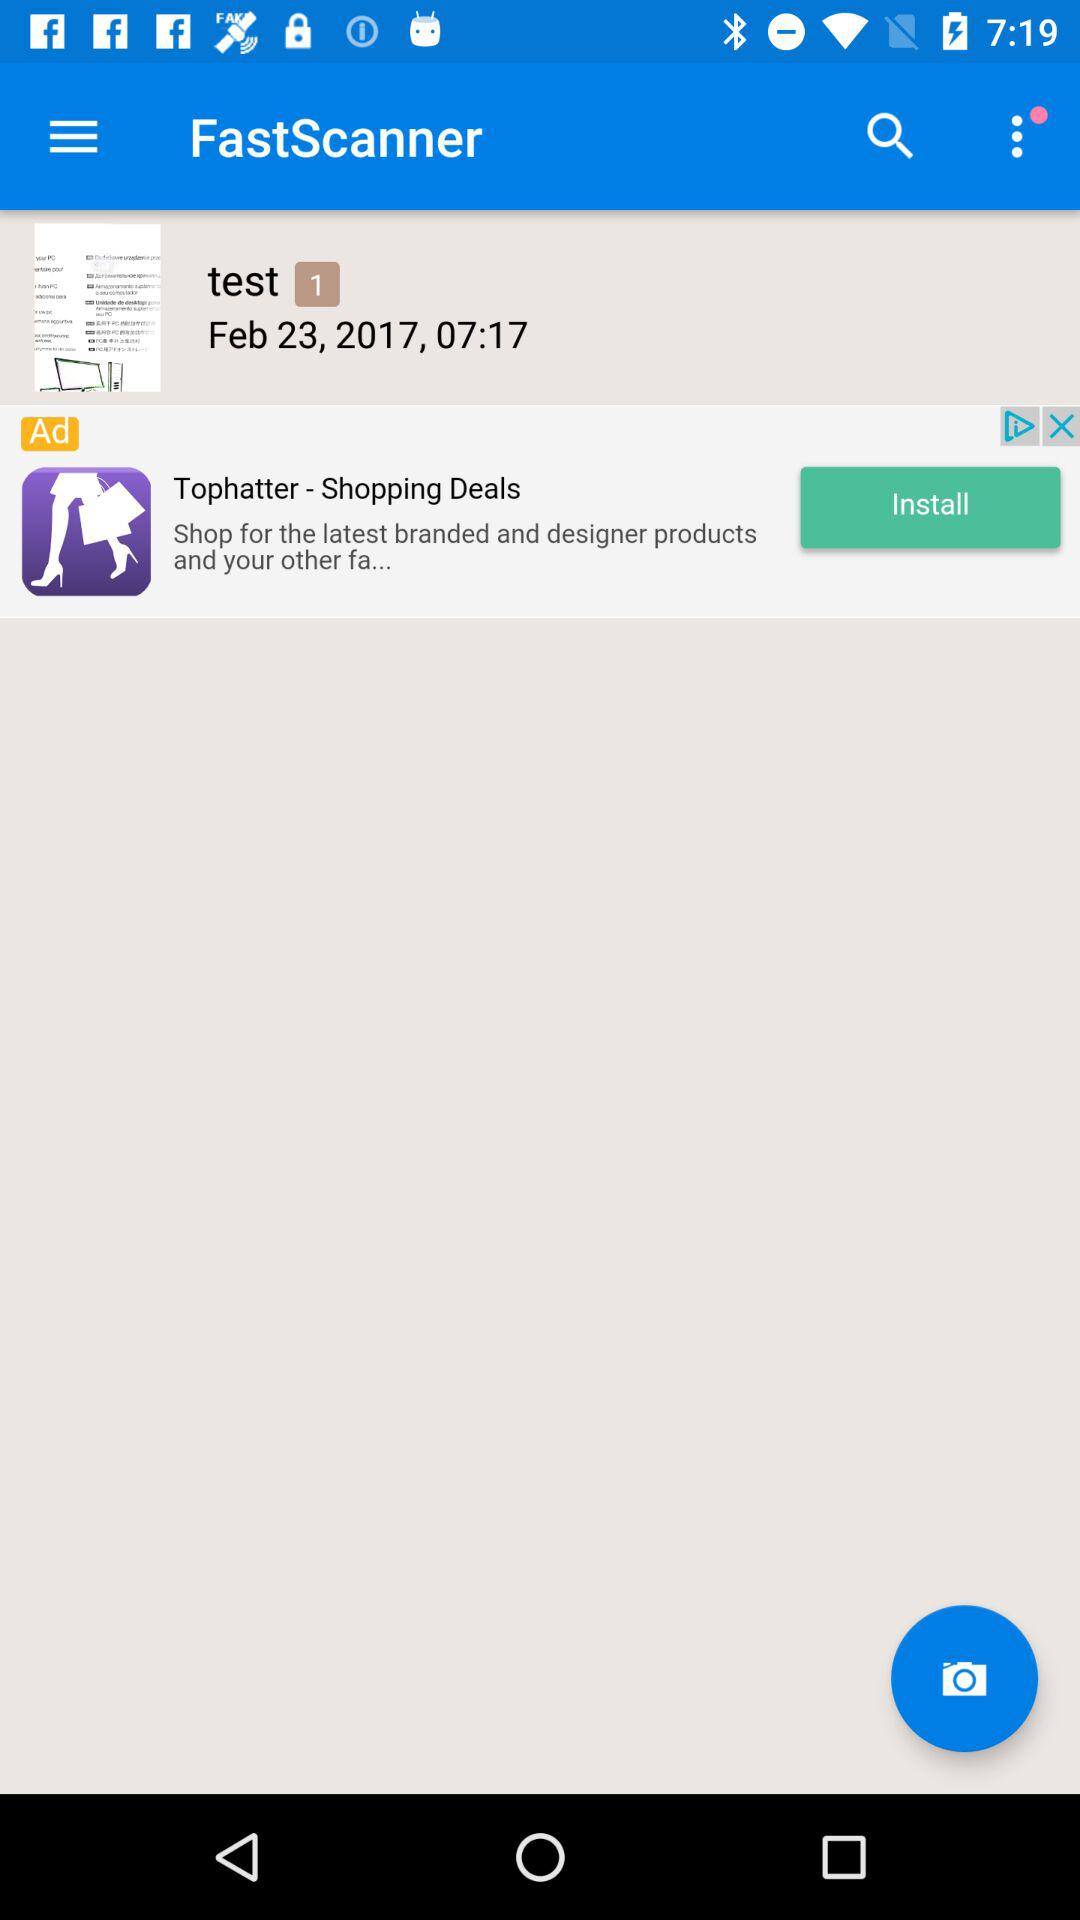What is the date of the file saved in the "FastScanner" application? The date of the file is February 23, 2017. 